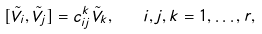<formula> <loc_0><loc_0><loc_500><loc_500>[ \tilde { V } _ { i } , \tilde { V } _ { j } ] = c ^ { k } _ { i j } \tilde { V } _ { k } , \quad i , j , k = 1 , \dots , r ,</formula> 